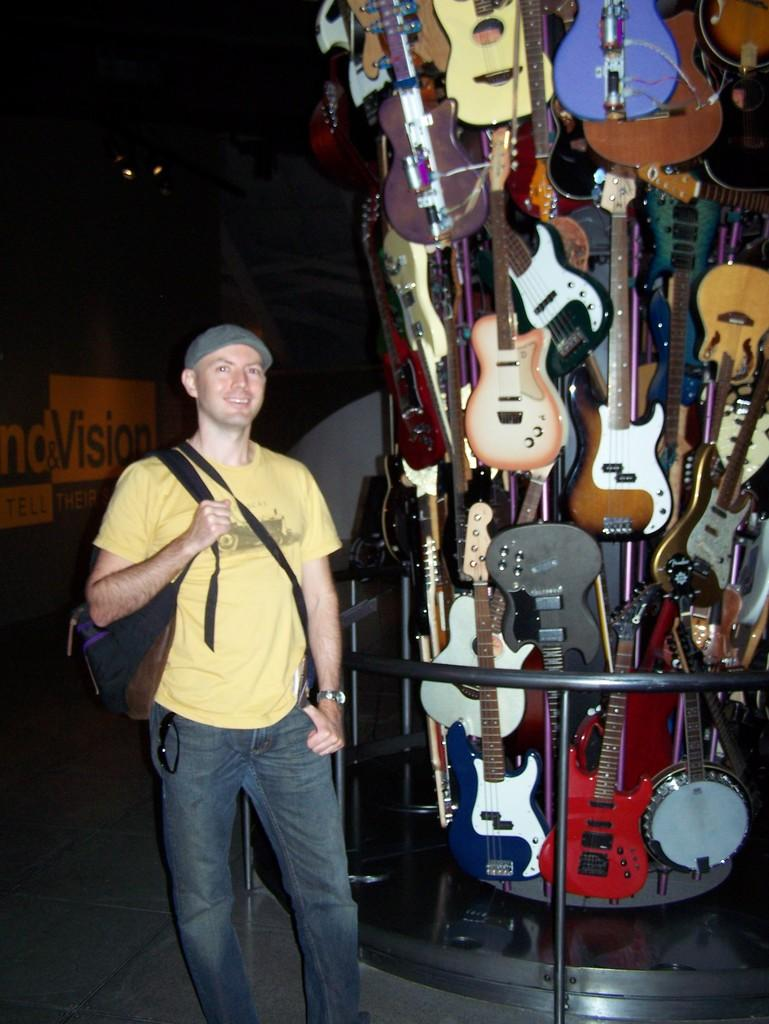What is the main subject of the image? There is a man standing in the image. What is the man wearing? The man is wearing a bag. What can be seen in the background of the image? There are guitars and a board in the background of the image. What type of ray is swimming in the image? There is no ray present in the image; it features a man standing with guitars and a board in the background. 